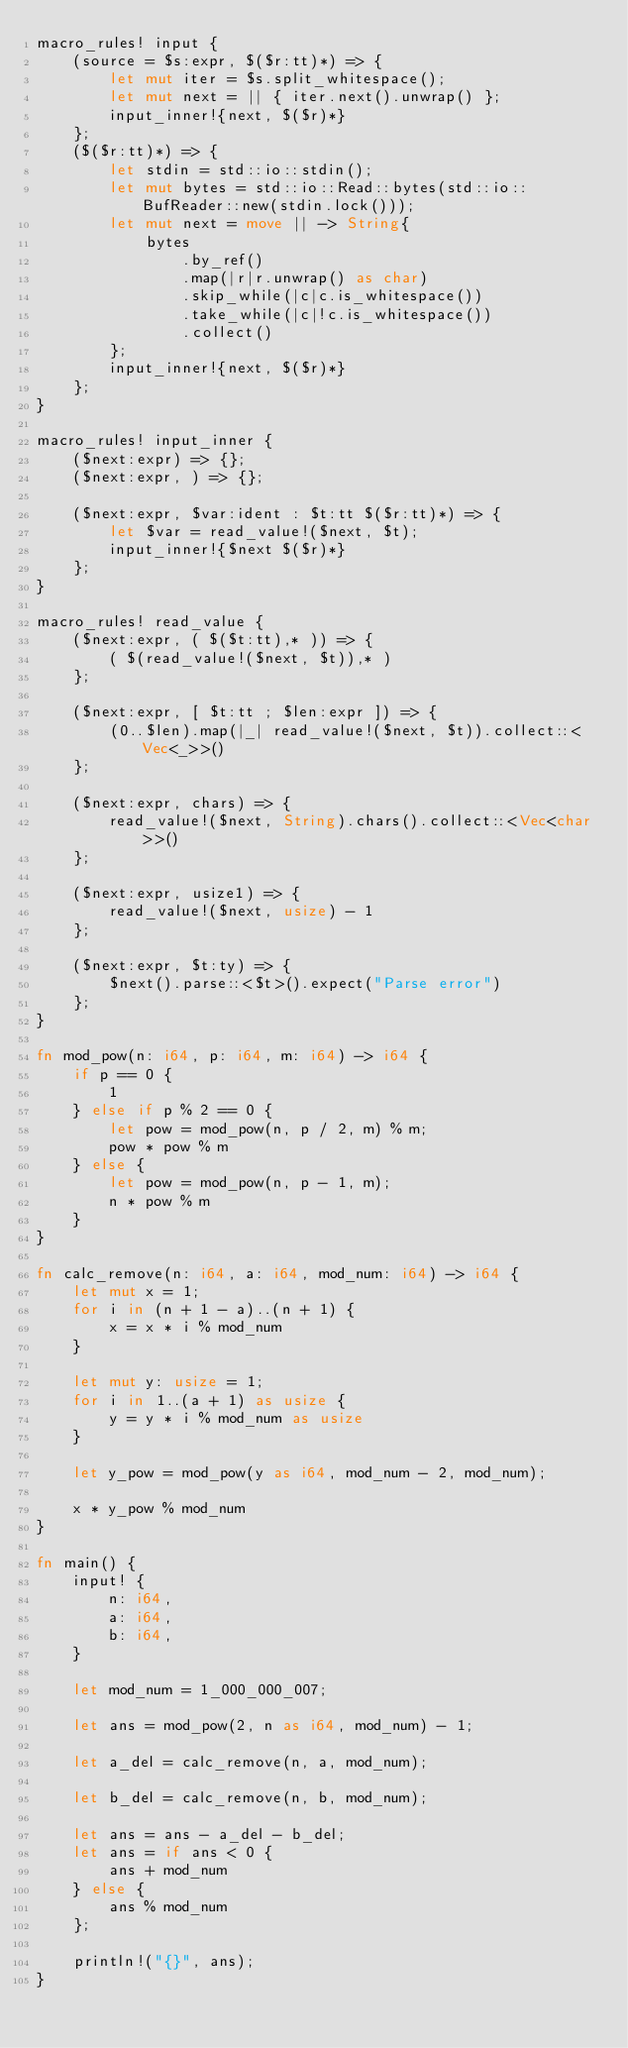Convert code to text. <code><loc_0><loc_0><loc_500><loc_500><_Rust_>macro_rules! input {
    (source = $s:expr, $($r:tt)*) => {
        let mut iter = $s.split_whitespace();
        let mut next = || { iter.next().unwrap() };
        input_inner!{next, $($r)*}
    };
    ($($r:tt)*) => {
        let stdin = std::io::stdin();
        let mut bytes = std::io::Read::bytes(std::io::BufReader::new(stdin.lock()));
        let mut next = move || -> String{
            bytes
                .by_ref()
                .map(|r|r.unwrap() as char)
                .skip_while(|c|c.is_whitespace())
                .take_while(|c|!c.is_whitespace())
                .collect()
        };
        input_inner!{next, $($r)*}
    };
}

macro_rules! input_inner {
    ($next:expr) => {};
    ($next:expr, ) => {};

    ($next:expr, $var:ident : $t:tt $($r:tt)*) => {
        let $var = read_value!($next, $t);
        input_inner!{$next $($r)*}
    };
}

macro_rules! read_value {
    ($next:expr, ( $($t:tt),* )) => {
        ( $(read_value!($next, $t)),* )
    };

    ($next:expr, [ $t:tt ; $len:expr ]) => {
        (0..$len).map(|_| read_value!($next, $t)).collect::<Vec<_>>()
    };

    ($next:expr, chars) => {
        read_value!($next, String).chars().collect::<Vec<char>>()
    };

    ($next:expr, usize1) => {
        read_value!($next, usize) - 1
    };

    ($next:expr, $t:ty) => {
        $next().parse::<$t>().expect("Parse error")
    };
}

fn mod_pow(n: i64, p: i64, m: i64) -> i64 {
    if p == 0 {
        1
    } else if p % 2 == 0 {
        let pow = mod_pow(n, p / 2, m) % m;
        pow * pow % m
    } else {
        let pow = mod_pow(n, p - 1, m);
        n * pow % m
    }
}

fn calc_remove(n: i64, a: i64, mod_num: i64) -> i64 {
    let mut x = 1;
    for i in (n + 1 - a)..(n + 1) {
        x = x * i % mod_num
    }

    let mut y: usize = 1;
    for i in 1..(a + 1) as usize {
        y = y * i % mod_num as usize
    }

    let y_pow = mod_pow(y as i64, mod_num - 2, mod_num);

    x * y_pow % mod_num
}

fn main() {
    input! {
        n: i64,
        a: i64,
        b: i64,
    }

    let mod_num = 1_000_000_007;

    let ans = mod_pow(2, n as i64, mod_num) - 1;

    let a_del = calc_remove(n, a, mod_num);

    let b_del = calc_remove(n, b, mod_num);

    let ans = ans - a_del - b_del;
    let ans = if ans < 0 {
        ans + mod_num
    } else {
        ans % mod_num
    };

    println!("{}", ans);
}
</code> 